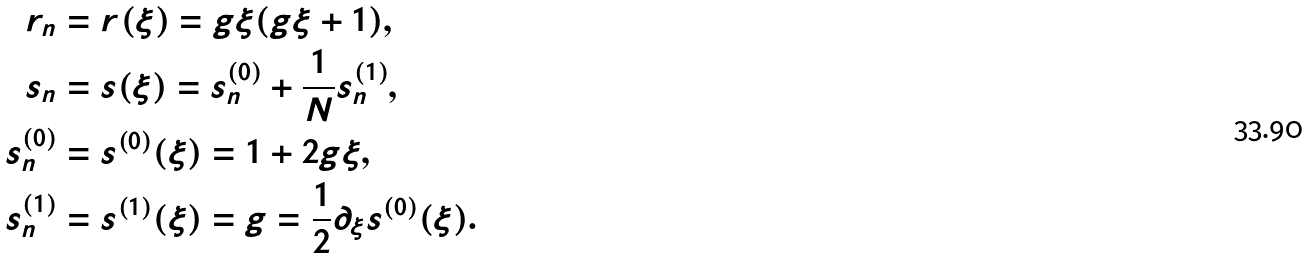Convert formula to latex. <formula><loc_0><loc_0><loc_500><loc_500>r _ { n } & = r ( \xi ) = g \xi ( g \xi + 1 ) , \\ s _ { n } & = s ( \xi ) = s _ { n } ^ { ( 0 ) } + \frac { 1 } { N } s _ { n } ^ { ( 1 ) } , \\ s _ { n } ^ { ( 0 ) } & = s ^ { ( 0 ) } ( \xi ) = 1 + 2 g \xi , \\ s _ { n } ^ { ( 1 ) } & = s ^ { ( 1 ) } ( \xi ) = g = \frac { 1 } { 2 } \partial _ { \xi } s ^ { ( 0 ) } ( \xi ) .</formula> 